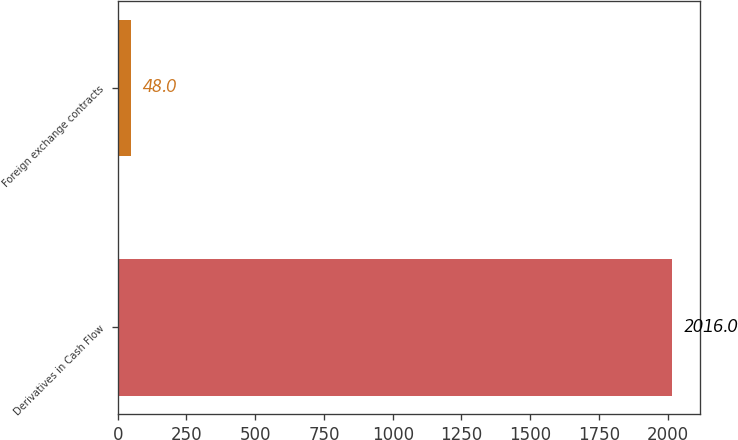Convert chart to OTSL. <chart><loc_0><loc_0><loc_500><loc_500><bar_chart><fcel>Derivatives in Cash Flow<fcel>Foreign exchange contracts<nl><fcel>2016<fcel>48<nl></chart> 